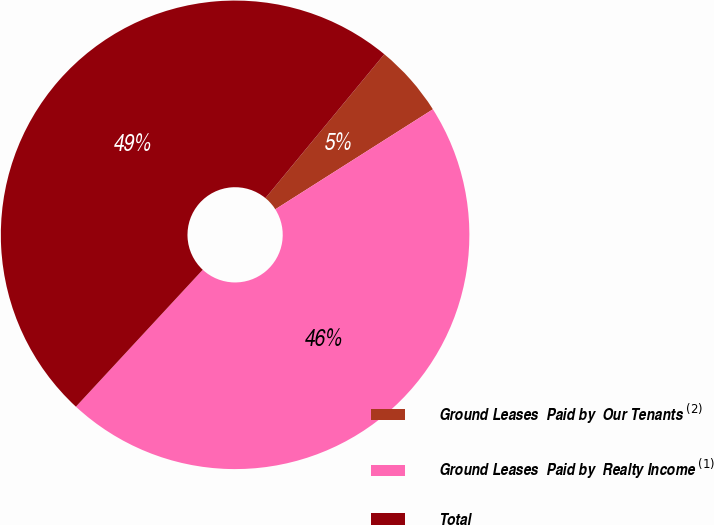Convert chart. <chart><loc_0><loc_0><loc_500><loc_500><pie_chart><fcel>Ground Leases  Paid by  Our Tenants $^{(2)}$<fcel>Ground Leases  Paid by  Realty Income $^{ (1)}$<fcel>Total<nl><fcel>5.01%<fcel>45.89%<fcel>49.1%<nl></chart> 